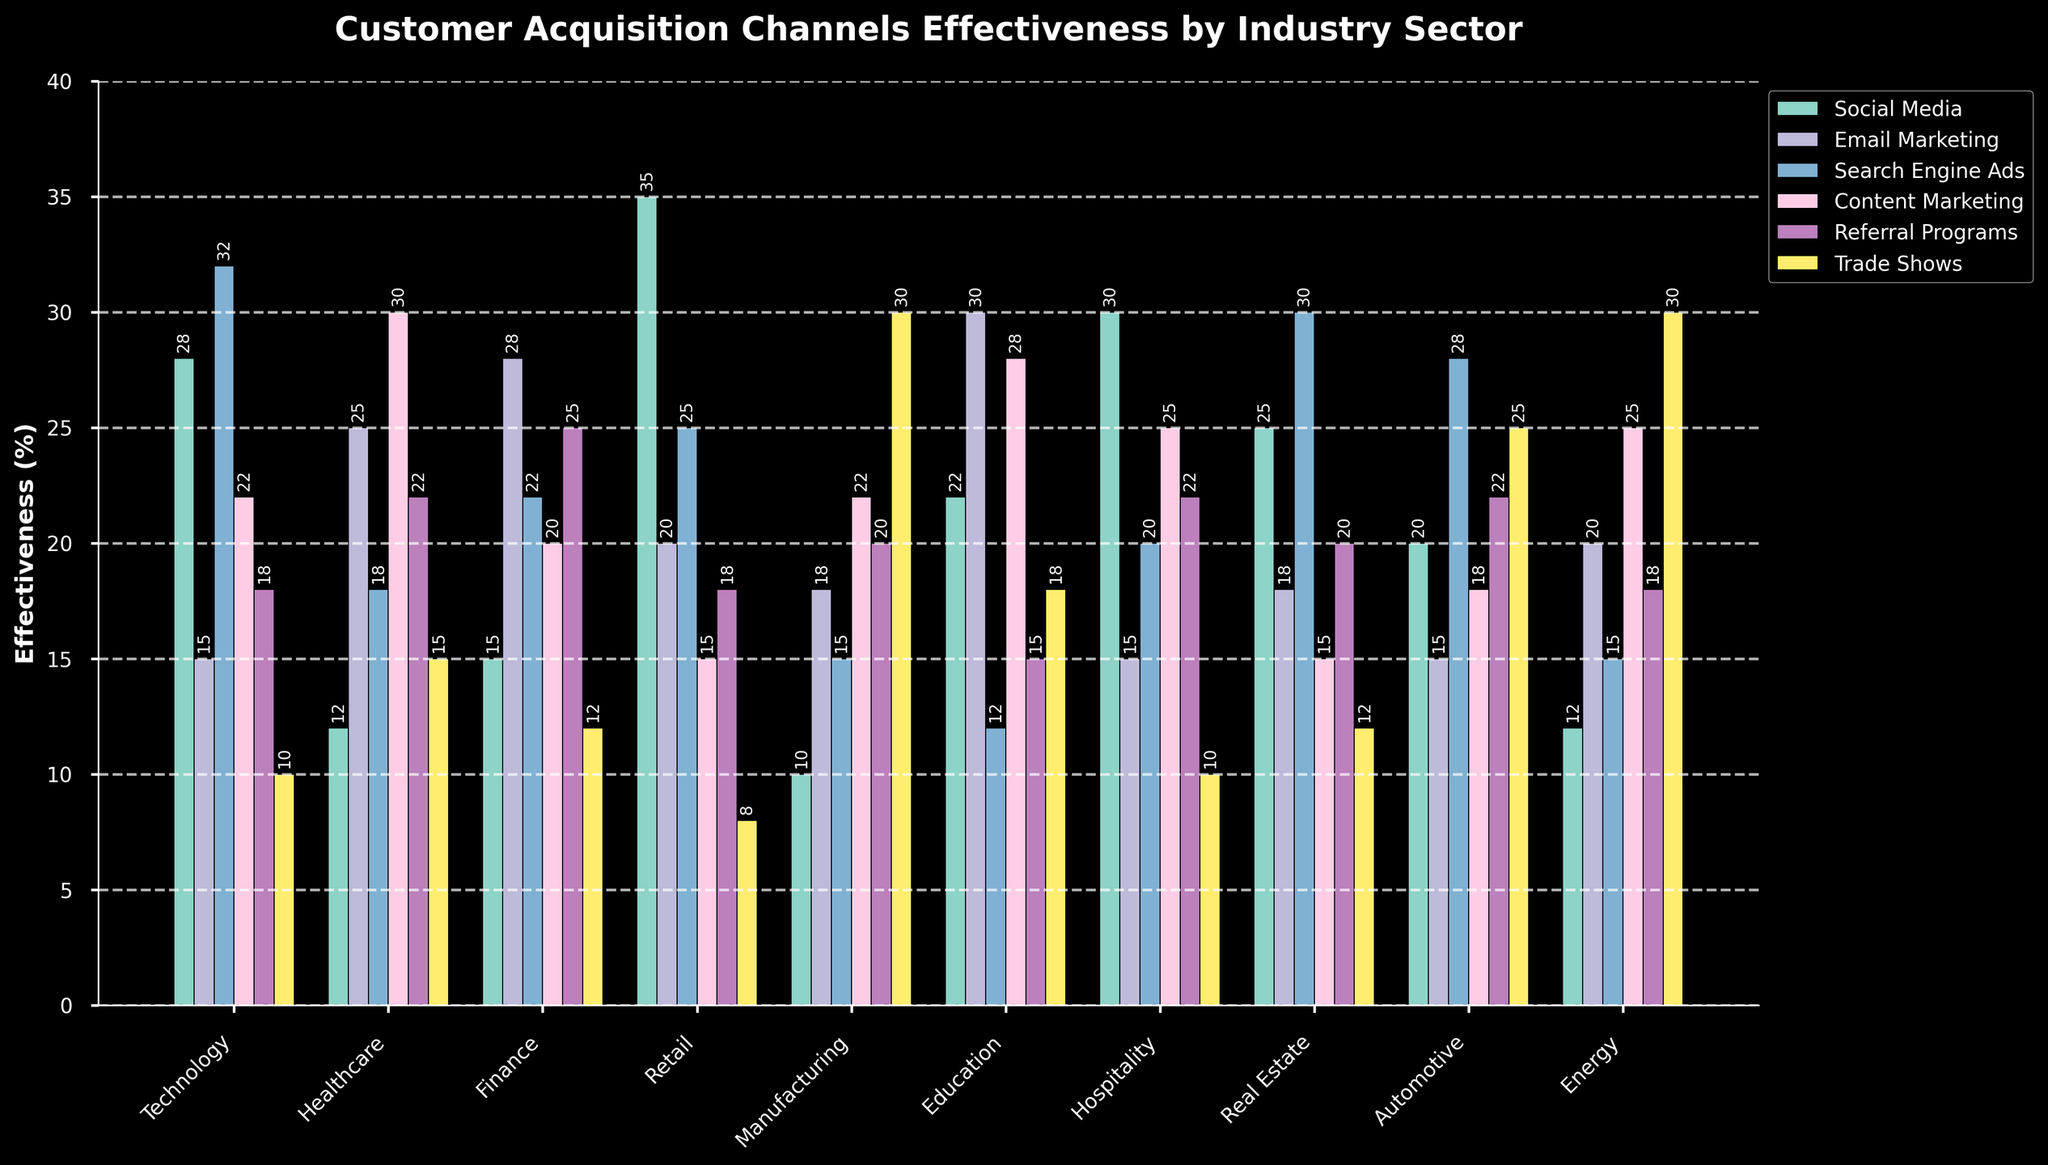Which industry sector finds Trade Shows the most effective for customer acquisition? From the figure, Manufacturing and Energy industries have the highest bar for Trade Shows at 30%, higher than any other industries.
Answer: Manufacturing, Energy Which channel is most effective for customer acquisition in the Technology sector? For the Technology sector, the tallest bar is for Search Engine Ads, indicating it is the most effective at 32%.
Answer: Search Engine Ads In which industry sector is Email Marketing the least effective for customer acquisition? By observing the heights of the bars for Email Marketing across all industries, Email Marketing is least effective in the Technology sector, at 15%.
Answer: Technology What is the total effectiveness percentage for Social Media and Content Marketing in the Retail sector? For the Retail sector, the effectiveness of Social Media is 35% and Content Marketing is 15%. Adding these values: 35 + 15 = 50.
Answer: 50% Which acquisition channel has the most consistent effectiveness across all industry sectors? By comparing the variation in bar heights across different channels, Referral Programs and Email Marketing appear to have the least variation in height, indicating more consistent effectiveness.
Answer: Referral Programs, Email Marketing Is Social Media more effective than Referral Programs in the Hospitality sector? For the Hospitality sector, the Social Media bar is at 30% and Referral Programs is at 22%. Since 30% is greater than 22%, Social Media is more effective.
Answer: Yes Which industry sector shows the highest overall effectiveness in customer acquisition through Content Marketing? By checking the topping bar for Content Marketing across all industries, Healthcare shows the highest effectiveness at 30%.
Answer: Healthcare Compare the effectiveness of Search Engine Ads and Trade Shows in the Automotive sector. In the Automotive sector, Search Engine Ads have a bar of 28%, whereas Trade Shows have a bar of 25%. Therefore, Search Engine Ads are more effective.
Answer: Search Engine Ads Among the given sectors, which one finds Search Engine Ads more effective than Social Media? By comparing the height of the bars for Search Engine Ads and Social Media for every sector, Finance and Real Estate sectors find Search Engine Ads (both with 30%) more effective than Social Media (both have less than 30%).
Answer: Finance, Real Estate 